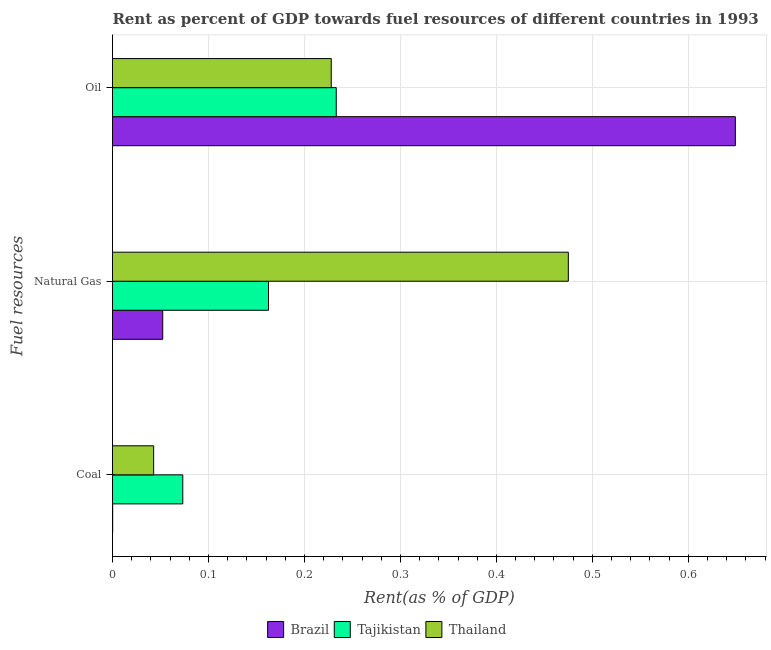How many different coloured bars are there?
Your answer should be very brief. 3. Are the number of bars per tick equal to the number of legend labels?
Your answer should be very brief. Yes. Are the number of bars on each tick of the Y-axis equal?
Ensure brevity in your answer.  Yes. What is the label of the 2nd group of bars from the top?
Give a very brief answer. Natural Gas. What is the rent towards oil in Tajikistan?
Your response must be concise. 0.23. Across all countries, what is the maximum rent towards natural gas?
Provide a succinct answer. 0.47. Across all countries, what is the minimum rent towards coal?
Ensure brevity in your answer.  0. In which country was the rent towards natural gas maximum?
Your answer should be compact. Thailand. In which country was the rent towards coal minimum?
Give a very brief answer. Brazil. What is the total rent towards natural gas in the graph?
Your response must be concise. 0.69. What is the difference between the rent towards oil in Brazil and that in Tajikistan?
Offer a very short reply. 0.42. What is the difference between the rent towards oil in Thailand and the rent towards coal in Tajikistan?
Your answer should be very brief. 0.15. What is the average rent towards oil per country?
Provide a succinct answer. 0.37. What is the difference between the rent towards natural gas and rent towards coal in Tajikistan?
Provide a short and direct response. 0.09. What is the ratio of the rent towards oil in Brazil to that in Tajikistan?
Provide a short and direct response. 2.78. Is the rent towards natural gas in Tajikistan less than that in Thailand?
Offer a terse response. Yes. Is the difference between the rent towards coal in Tajikistan and Thailand greater than the difference between the rent towards oil in Tajikistan and Thailand?
Offer a terse response. Yes. What is the difference between the highest and the second highest rent towards coal?
Offer a very short reply. 0.03. What is the difference between the highest and the lowest rent towards oil?
Your answer should be compact. 0.42. In how many countries, is the rent towards coal greater than the average rent towards coal taken over all countries?
Ensure brevity in your answer.  2. What does the 2nd bar from the top in Coal represents?
Offer a very short reply. Tajikistan. Is it the case that in every country, the sum of the rent towards coal and rent towards natural gas is greater than the rent towards oil?
Make the answer very short. No. What is the difference between two consecutive major ticks on the X-axis?
Make the answer very short. 0.1. How many legend labels are there?
Provide a short and direct response. 3. What is the title of the graph?
Provide a short and direct response. Rent as percent of GDP towards fuel resources of different countries in 1993. Does "India" appear as one of the legend labels in the graph?
Give a very brief answer. No. What is the label or title of the X-axis?
Give a very brief answer. Rent(as % of GDP). What is the label or title of the Y-axis?
Your response must be concise. Fuel resources. What is the Rent(as % of GDP) in Brazil in Coal?
Give a very brief answer. 0. What is the Rent(as % of GDP) in Tajikistan in Coal?
Provide a succinct answer. 0.07. What is the Rent(as % of GDP) in Thailand in Coal?
Make the answer very short. 0.04. What is the Rent(as % of GDP) in Brazil in Natural Gas?
Keep it short and to the point. 0.05. What is the Rent(as % of GDP) in Tajikistan in Natural Gas?
Keep it short and to the point. 0.16. What is the Rent(as % of GDP) in Thailand in Natural Gas?
Make the answer very short. 0.47. What is the Rent(as % of GDP) of Brazil in Oil?
Your answer should be compact. 0.65. What is the Rent(as % of GDP) of Tajikistan in Oil?
Keep it short and to the point. 0.23. What is the Rent(as % of GDP) of Thailand in Oil?
Make the answer very short. 0.23. Across all Fuel resources, what is the maximum Rent(as % of GDP) in Brazil?
Make the answer very short. 0.65. Across all Fuel resources, what is the maximum Rent(as % of GDP) of Tajikistan?
Your answer should be compact. 0.23. Across all Fuel resources, what is the maximum Rent(as % of GDP) in Thailand?
Your response must be concise. 0.47. Across all Fuel resources, what is the minimum Rent(as % of GDP) of Brazil?
Make the answer very short. 0. Across all Fuel resources, what is the minimum Rent(as % of GDP) of Tajikistan?
Your response must be concise. 0.07. Across all Fuel resources, what is the minimum Rent(as % of GDP) in Thailand?
Provide a succinct answer. 0.04. What is the total Rent(as % of GDP) of Brazil in the graph?
Ensure brevity in your answer.  0.7. What is the total Rent(as % of GDP) of Tajikistan in the graph?
Ensure brevity in your answer.  0.47. What is the total Rent(as % of GDP) in Thailand in the graph?
Ensure brevity in your answer.  0.75. What is the difference between the Rent(as % of GDP) in Brazil in Coal and that in Natural Gas?
Provide a short and direct response. -0.05. What is the difference between the Rent(as % of GDP) of Tajikistan in Coal and that in Natural Gas?
Offer a very short reply. -0.09. What is the difference between the Rent(as % of GDP) of Thailand in Coal and that in Natural Gas?
Ensure brevity in your answer.  -0.43. What is the difference between the Rent(as % of GDP) in Brazil in Coal and that in Oil?
Keep it short and to the point. -0.65. What is the difference between the Rent(as % of GDP) in Tajikistan in Coal and that in Oil?
Offer a very short reply. -0.16. What is the difference between the Rent(as % of GDP) of Thailand in Coal and that in Oil?
Provide a succinct answer. -0.18. What is the difference between the Rent(as % of GDP) in Brazil in Natural Gas and that in Oil?
Give a very brief answer. -0.6. What is the difference between the Rent(as % of GDP) in Tajikistan in Natural Gas and that in Oil?
Provide a short and direct response. -0.07. What is the difference between the Rent(as % of GDP) in Thailand in Natural Gas and that in Oil?
Give a very brief answer. 0.25. What is the difference between the Rent(as % of GDP) in Brazil in Coal and the Rent(as % of GDP) in Tajikistan in Natural Gas?
Provide a short and direct response. -0.16. What is the difference between the Rent(as % of GDP) in Brazil in Coal and the Rent(as % of GDP) in Thailand in Natural Gas?
Offer a terse response. -0.47. What is the difference between the Rent(as % of GDP) in Tajikistan in Coal and the Rent(as % of GDP) in Thailand in Natural Gas?
Your answer should be compact. -0.4. What is the difference between the Rent(as % of GDP) in Brazil in Coal and the Rent(as % of GDP) in Tajikistan in Oil?
Your answer should be compact. -0.23. What is the difference between the Rent(as % of GDP) of Brazil in Coal and the Rent(as % of GDP) of Thailand in Oil?
Provide a succinct answer. -0.23. What is the difference between the Rent(as % of GDP) of Tajikistan in Coal and the Rent(as % of GDP) of Thailand in Oil?
Provide a succinct answer. -0.15. What is the difference between the Rent(as % of GDP) of Brazil in Natural Gas and the Rent(as % of GDP) of Tajikistan in Oil?
Provide a succinct answer. -0.18. What is the difference between the Rent(as % of GDP) in Brazil in Natural Gas and the Rent(as % of GDP) in Thailand in Oil?
Offer a very short reply. -0.18. What is the difference between the Rent(as % of GDP) in Tajikistan in Natural Gas and the Rent(as % of GDP) in Thailand in Oil?
Provide a short and direct response. -0.07. What is the average Rent(as % of GDP) of Brazil per Fuel resources?
Your answer should be very brief. 0.23. What is the average Rent(as % of GDP) of Tajikistan per Fuel resources?
Your answer should be compact. 0.16. What is the average Rent(as % of GDP) of Thailand per Fuel resources?
Offer a terse response. 0.25. What is the difference between the Rent(as % of GDP) in Brazil and Rent(as % of GDP) in Tajikistan in Coal?
Provide a short and direct response. -0.07. What is the difference between the Rent(as % of GDP) in Brazil and Rent(as % of GDP) in Thailand in Coal?
Offer a terse response. -0.04. What is the difference between the Rent(as % of GDP) of Tajikistan and Rent(as % of GDP) of Thailand in Coal?
Your answer should be very brief. 0.03. What is the difference between the Rent(as % of GDP) in Brazil and Rent(as % of GDP) in Tajikistan in Natural Gas?
Your answer should be very brief. -0.11. What is the difference between the Rent(as % of GDP) of Brazil and Rent(as % of GDP) of Thailand in Natural Gas?
Give a very brief answer. -0.42. What is the difference between the Rent(as % of GDP) in Tajikistan and Rent(as % of GDP) in Thailand in Natural Gas?
Your response must be concise. -0.31. What is the difference between the Rent(as % of GDP) in Brazil and Rent(as % of GDP) in Tajikistan in Oil?
Offer a very short reply. 0.42. What is the difference between the Rent(as % of GDP) of Brazil and Rent(as % of GDP) of Thailand in Oil?
Your answer should be compact. 0.42. What is the difference between the Rent(as % of GDP) in Tajikistan and Rent(as % of GDP) in Thailand in Oil?
Your response must be concise. 0.01. What is the ratio of the Rent(as % of GDP) in Brazil in Coal to that in Natural Gas?
Keep it short and to the point. 0. What is the ratio of the Rent(as % of GDP) in Tajikistan in Coal to that in Natural Gas?
Offer a very short reply. 0.45. What is the ratio of the Rent(as % of GDP) of Thailand in Coal to that in Natural Gas?
Provide a short and direct response. 0.09. What is the ratio of the Rent(as % of GDP) of Tajikistan in Coal to that in Oil?
Your response must be concise. 0.31. What is the ratio of the Rent(as % of GDP) of Thailand in Coal to that in Oil?
Your response must be concise. 0.19. What is the ratio of the Rent(as % of GDP) in Brazil in Natural Gas to that in Oil?
Ensure brevity in your answer.  0.08. What is the ratio of the Rent(as % of GDP) of Tajikistan in Natural Gas to that in Oil?
Your response must be concise. 0.7. What is the ratio of the Rent(as % of GDP) of Thailand in Natural Gas to that in Oil?
Give a very brief answer. 2.08. What is the difference between the highest and the second highest Rent(as % of GDP) of Brazil?
Your response must be concise. 0.6. What is the difference between the highest and the second highest Rent(as % of GDP) of Tajikistan?
Give a very brief answer. 0.07. What is the difference between the highest and the second highest Rent(as % of GDP) of Thailand?
Provide a short and direct response. 0.25. What is the difference between the highest and the lowest Rent(as % of GDP) in Brazil?
Offer a terse response. 0.65. What is the difference between the highest and the lowest Rent(as % of GDP) in Tajikistan?
Your response must be concise. 0.16. What is the difference between the highest and the lowest Rent(as % of GDP) of Thailand?
Offer a very short reply. 0.43. 